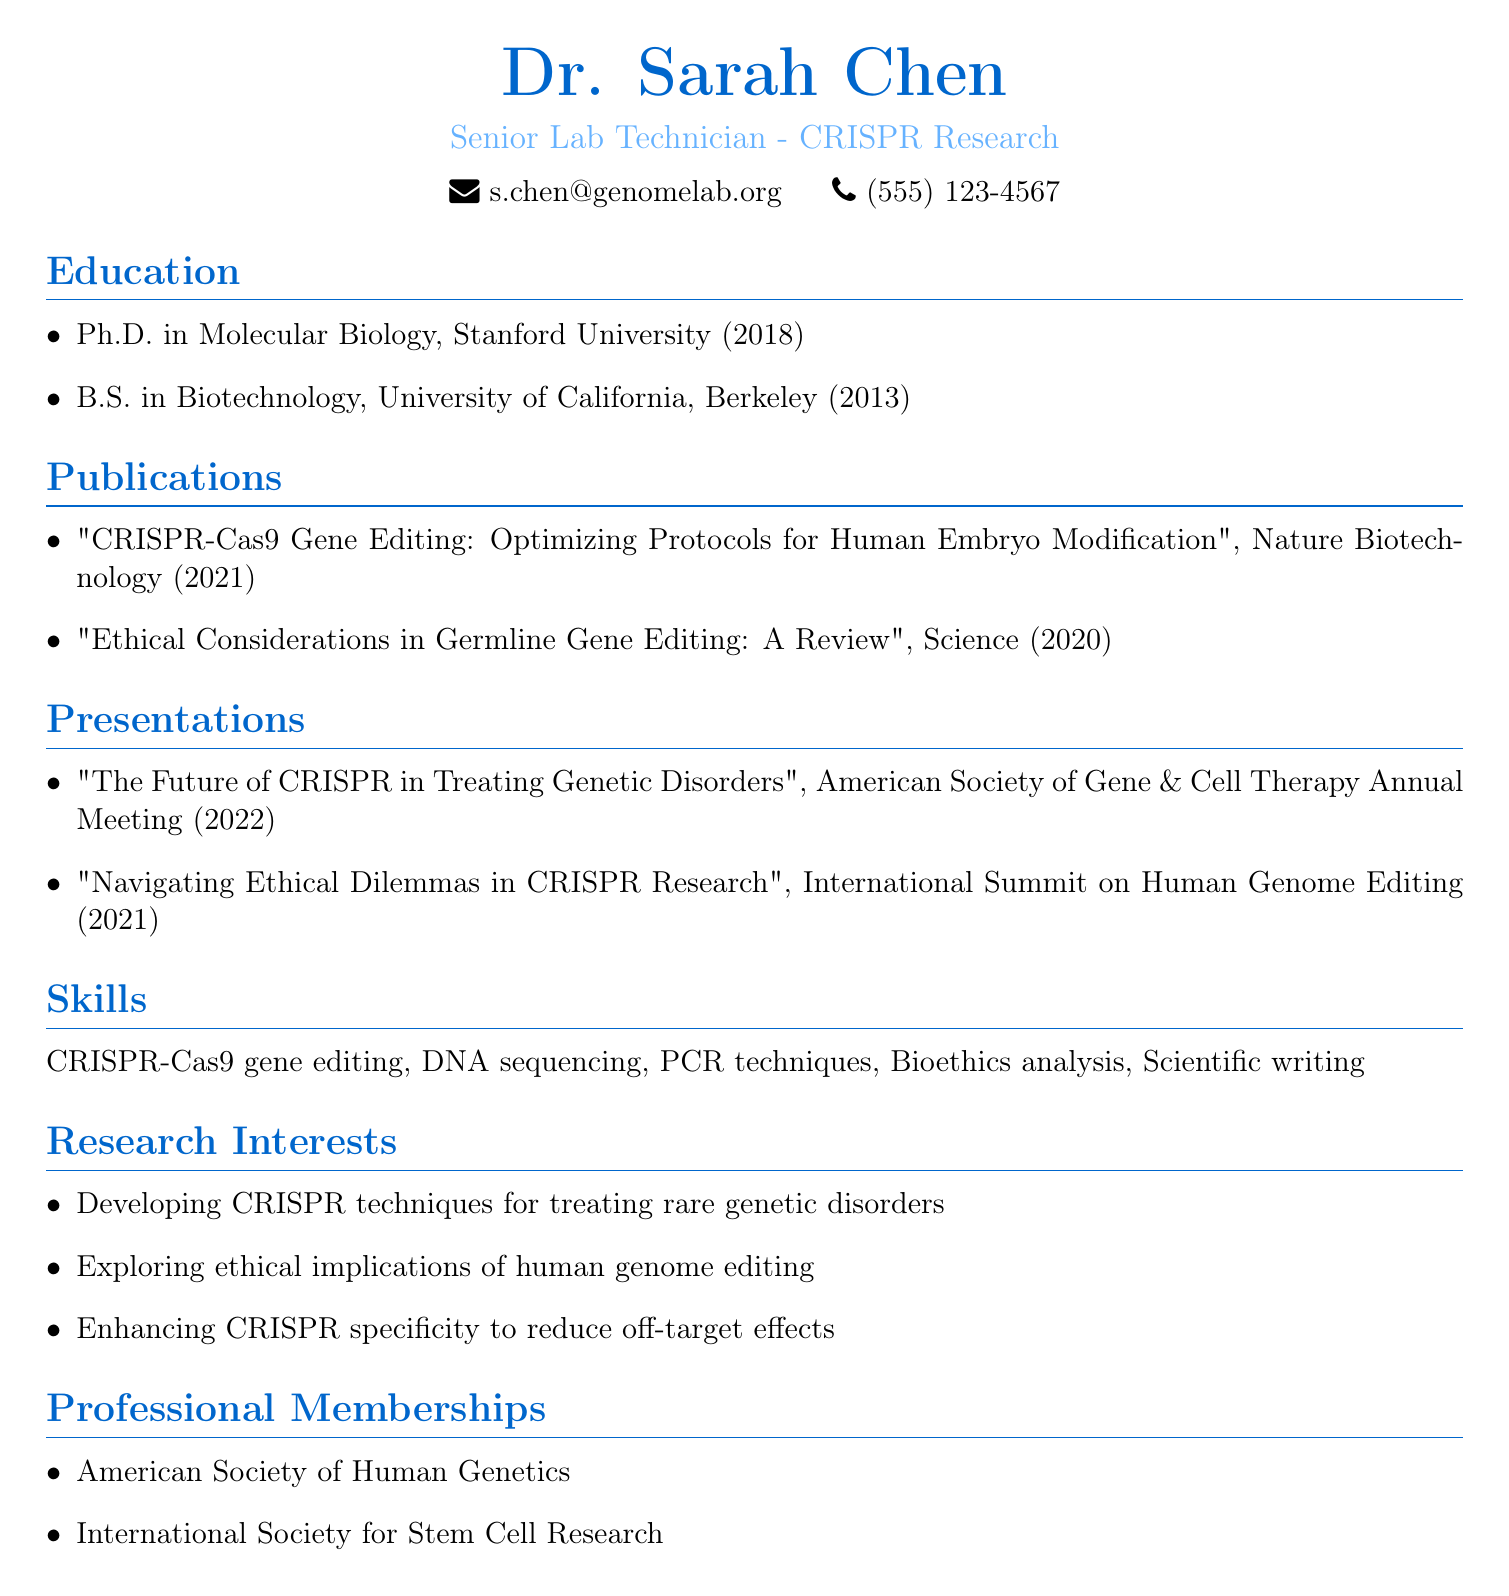what is the name of the individual in the resume? The individual is named Dr. Sarah Chen, as stated at the top of the document.
Answer: Dr. Sarah Chen what is the title of the publication from 2021? The title of the publication from 2021 is listed under publications and is "CRISPR-Cas9 Gene Editing: Optimizing Protocols for Human Embryo Modification."
Answer: "CRISPR-Cas9 Gene Editing: Optimizing Protocols for Human Embryo Modification" in what year was the Ph.D. obtained? The year 2018 is mentioned next to the Ph.D. degree in the education section.
Answer: 2018 how many professional memberships are listed? The document states that there are two professional memberships listed under professional memberships.
Answer: 2 which conference hosted the presentation in 2022? The presentation titled "The Future of CRISPR in Treating Genetic Disorders" was presented at the American Society of Gene & Cell Therapy Annual Meeting in 2022.
Answer: American Society of Gene & Cell Therapy Annual Meeting what is one of Dr. Chen's research interests? The document outlines several research interests; one mentioned is "Developing CRISPR techniques for treating rare genetic disorders."
Answer: Developing CRISPR techniques for treating rare genetic disorders what university did Dr. Chen attend for her undergraduate degree? The undergraduate degree is specified as a B.S. in Biotechnology from the University of California, Berkeley.
Answer: University of California, Berkeley what type of analysis is mentioned under skills? Bioethics analysis is listed as one of the skills in the document.
Answer: Bioethics analysis 